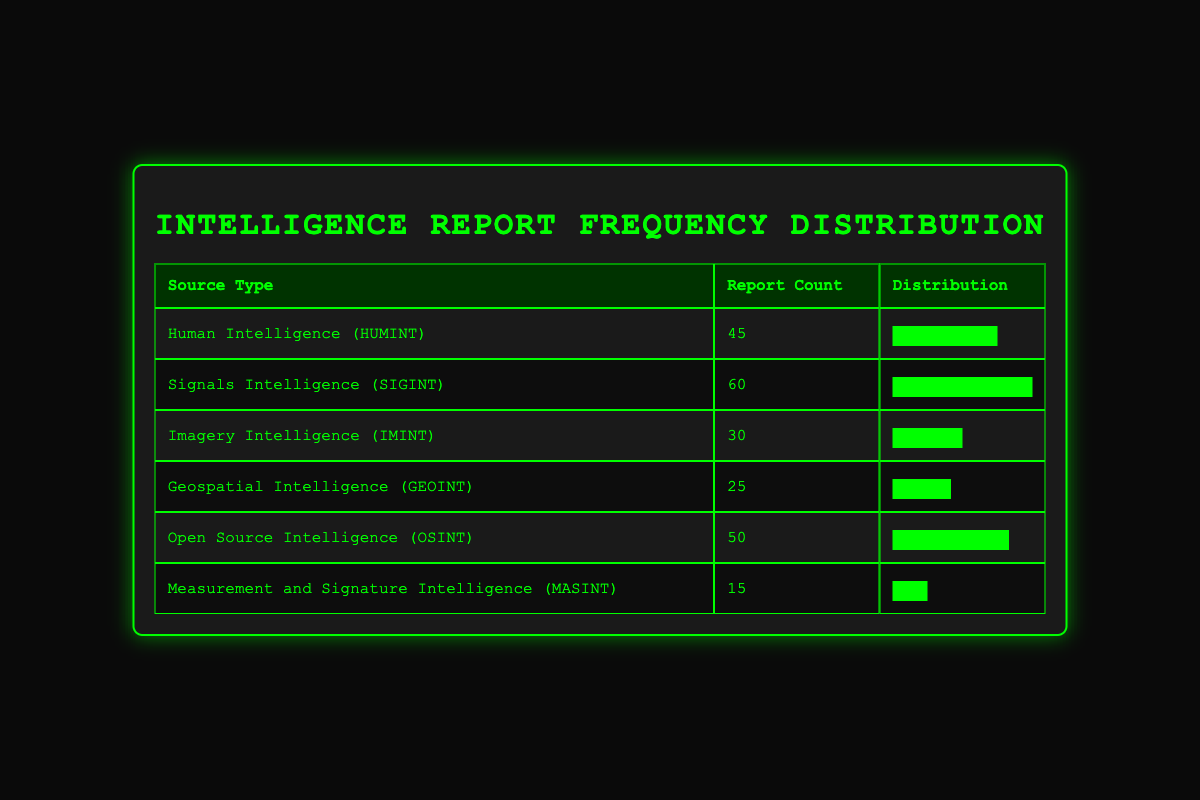What is the highest number of reports from a single source? Signals Intelligence (SIGINT) has the highest number of reports, with a count of 60.
Answer: 60 Which source has fewer reports than Open Source Intelligence (OSINT)? Open Source Intelligence (OSINT) has 50 reports. The sources with fewer reports are Imagery Intelligence (IMINT) with 30, Geospatial Intelligence (GEOINT) with 25, and Measurement and Signature Intelligence (MASINT) with 15.
Answer: IMINT, GEOINT, MASINT Is the total number of reports from Human Intelligence (HUMINT) and Imagery Intelligence (IMINT) greater than that from Signals Intelligence (SIGINT)? The total for HUMINT and IMINT is 45 + 30 = 75, which is greater than SIGINT's 60 reports.
Answer: Yes What percentage of the total reports does Measurement and Signature Intelligence (MASINT) represent? The total number of reports is 45 + 60 + 30 + 25 + 50 + 15 = 225. The percentage for MASINT is (15/225) * 100 = 6.67%.
Answer: 6.67% Which two sources together have the closest report count to Signals Intelligence (SIGINT)? To find sources close to 60 reports, combining Human Intelligence (HUMINT, 45) and Open Source Intelligence (OSINT, 50) gives 95, while combining Imagery Intelligence (IMINT, 30) and Geospatial Intelligence (GEOINT, 25) gives 55. HUMINT and OSINT are closest to SIGINT.
Answer: HUMINT and OSINT How many total reports are generated by the remaining sources if we exclude Signals Intelligence (SIGINT)? Excluding SIGINT (60 reports), the remaining sources add up to 45 + 30 + 25 + 50 + 15 = 165.
Answer: 165 Is it true that the total number of reports from Human Intelligence (HUMINT) and Open Source Intelligence (OSINT) exceeds that of Geospatial Intelligence (GEOINT)? HUMINT has 45 reports and OSINT has 50, totaling 95; GEOINT has 25 reports, so 95 exceeds 25.
Answer: Yes What is the average number of reports for the six different source types? The total number of reports is 225 (sum of all reports), and there are 6 source types. The average is calculated as 225/6 = 37.5.
Answer: 37.5 